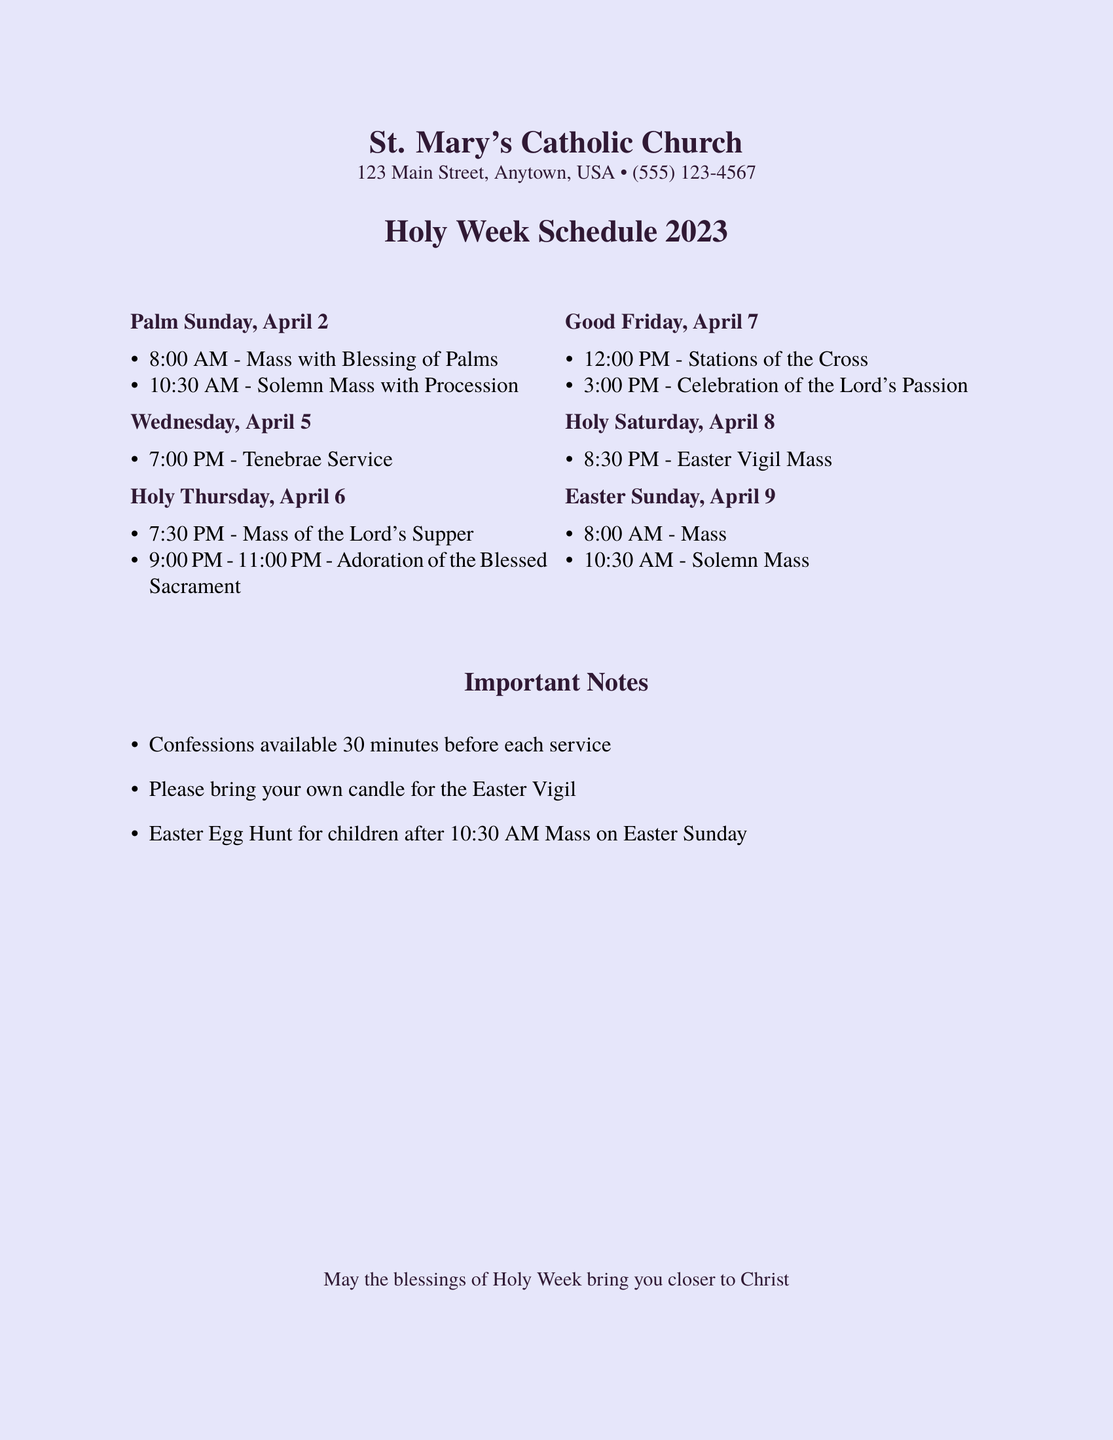What time is the Tenebrae Service? The document specifies that the Tenebrae Service is at 7:00 PM on April 5.
Answer: 7:00 PM What event takes place on Holy Thursday? The document lists the Mass of the Lord's Supper at 7:30 PM on Holy Thursday.
Answer: Mass of the Lord's Supper When is the Easter Vigil Mass? The Easter Vigil Mass is scheduled for 8:30 PM on Holy Saturday.
Answer: 8:30 PM How long does the Adoration of the Blessed Sacrament last on Holy Thursday? The document states that Adoration lasts from 9:00 PM to 11:00 PM on Holy Thursday, totaling 2 hours.
Answer: 2 hours What is the location of the events? The document indicates that the church is St. Mary's Catholic Church, located at 123 Main Street, Anytown, USA.
Answer: St. Mary's Catholic Church On which day is the Easter Egg Hunt scheduled? The Easter Egg Hunt is planned for Easter Sunday after the 10:30 AM Mass.
Answer: Easter Sunday How many Masses are there on Easter Sunday? The document lists two Masses on Easter Sunday: 8:00 AM and 10:30 AM.
Answer: Two What important note is mentioned regarding the Easter Vigil? The document reminds attendees to bring their own candle for the Easter Vigil.
Answer: Bring your own candle What is the significance of Palm Sunday in this document? The document marks Palm Sunday with a Mass that includes the Blessing of Palms at 8:00 AM.
Answer: Blessing of Palms 